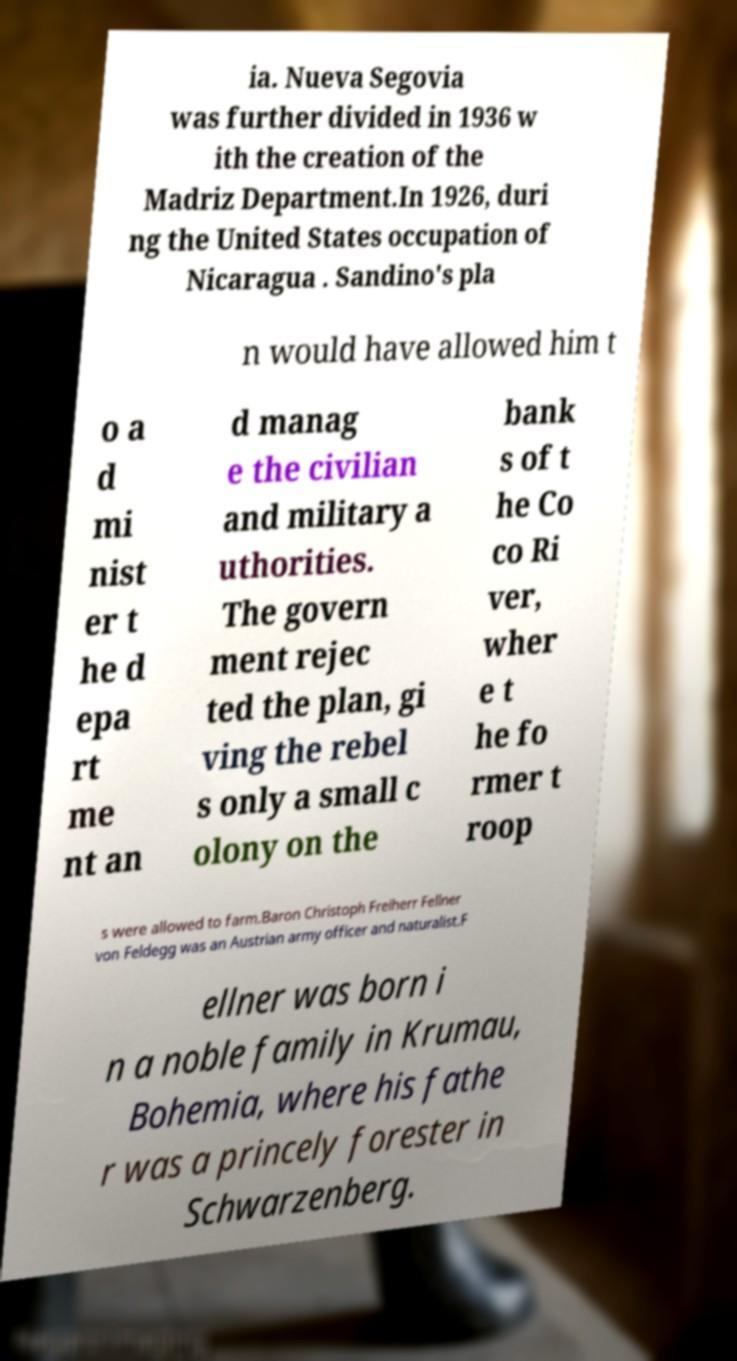Could you assist in decoding the text presented in this image and type it out clearly? ia. Nueva Segovia was further divided in 1936 w ith the creation of the Madriz Department.In 1926, duri ng the United States occupation of Nicaragua . Sandino's pla n would have allowed him t o a d mi nist er t he d epa rt me nt an d manag e the civilian and military a uthorities. The govern ment rejec ted the plan, gi ving the rebel s only a small c olony on the bank s of t he Co co Ri ver, wher e t he fo rmer t roop s were allowed to farm.Baron Christoph Freiherr Fellner von Feldegg was an Austrian army officer and naturalist.F ellner was born i n a noble family in Krumau, Bohemia, where his fathe r was a princely forester in Schwarzenberg. 